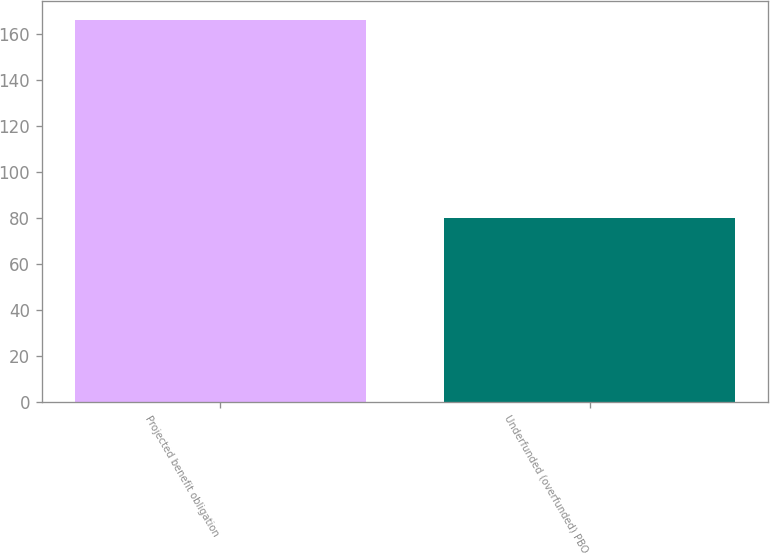<chart> <loc_0><loc_0><loc_500><loc_500><bar_chart><fcel>Projected benefit obligation<fcel>Underfunded (overfunded) PBO<nl><fcel>166<fcel>80<nl></chart> 